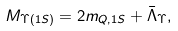<formula> <loc_0><loc_0><loc_500><loc_500>M _ { \Upsilon ( 1 S ) } = 2 m _ { Q , 1 S } + \bar { \Lambda } _ { \Upsilon } ,</formula> 